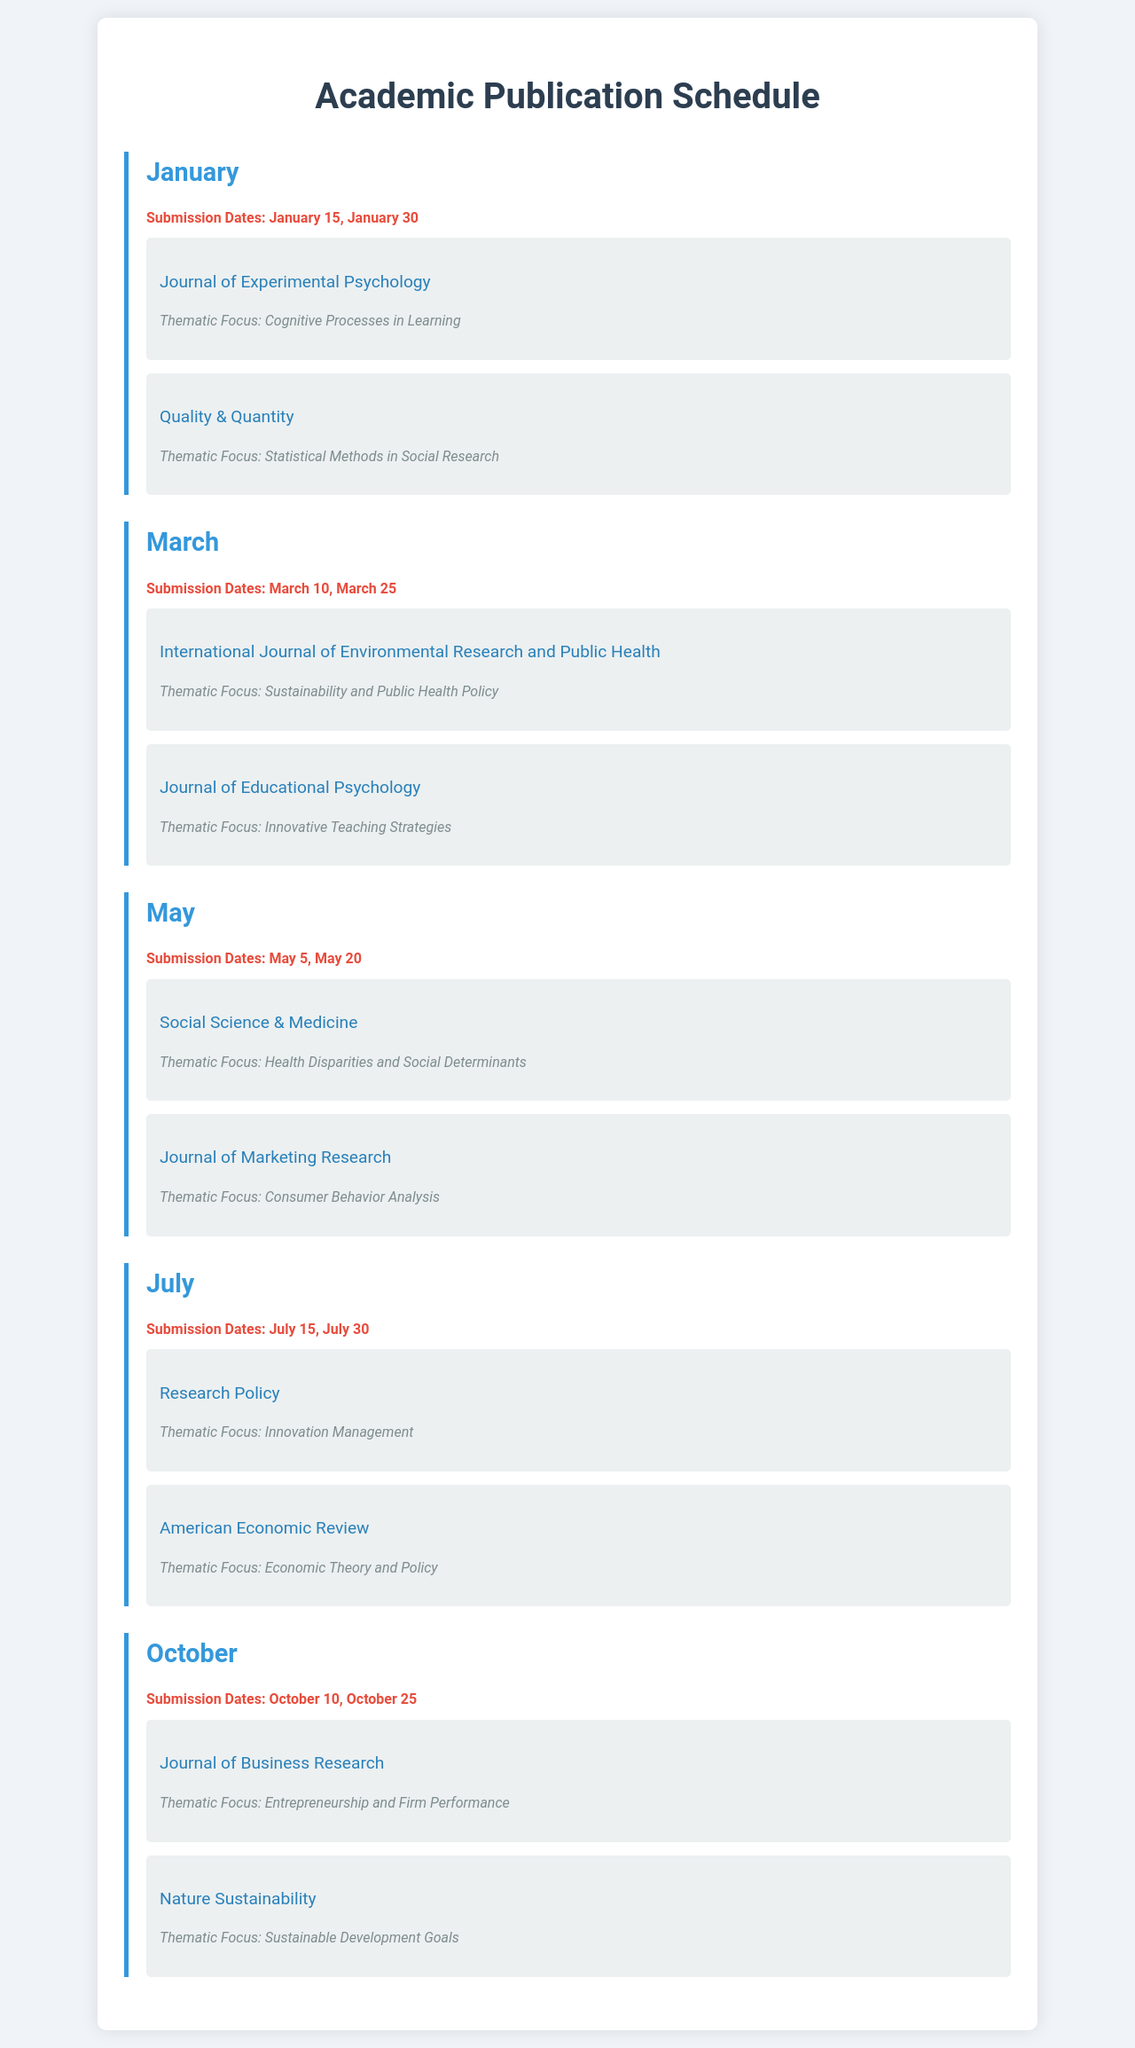what are the submission dates for January? The document lists the submission dates for January as January 15 and January 30.
Answer: January 15, January 30 which journal has the thematic focus on "Consumer Behavior Analysis"? The journal that focuses on "Consumer Behavior Analysis" is mentioned under May.
Answer: Journal of Marketing Research how many submissions are planned for July? The document specifies two submission dates for July.
Answer: 2 what is the thematic focus of the "International Journal of Environmental Research and Public Health"? The thematic focus is Sustainability and Public Health Policy.
Answer: Sustainability and Public Health Policy which month has a submission date of March 25? The submission date of March 25 is listed under March.
Answer: March name one journal scheduled for submission in October. The document provides a list of journals scheduled for submission in October, one of them is the Journal of Business Research.
Answer: Journal of Business Research what is the thematic focus for the "American Economic Review"? The thematic focus for the American Economic Review is Economic Theory and Policy.
Answer: Economic Theory and Policy in which month is the submission for "Social Science & Medicine" planned? The submission for "Social Science & Medicine" is planned for May.
Answer: May what are the submission dates for March? The submission dates for March are March 10 and March 25.
Answer: March 10, March 25 